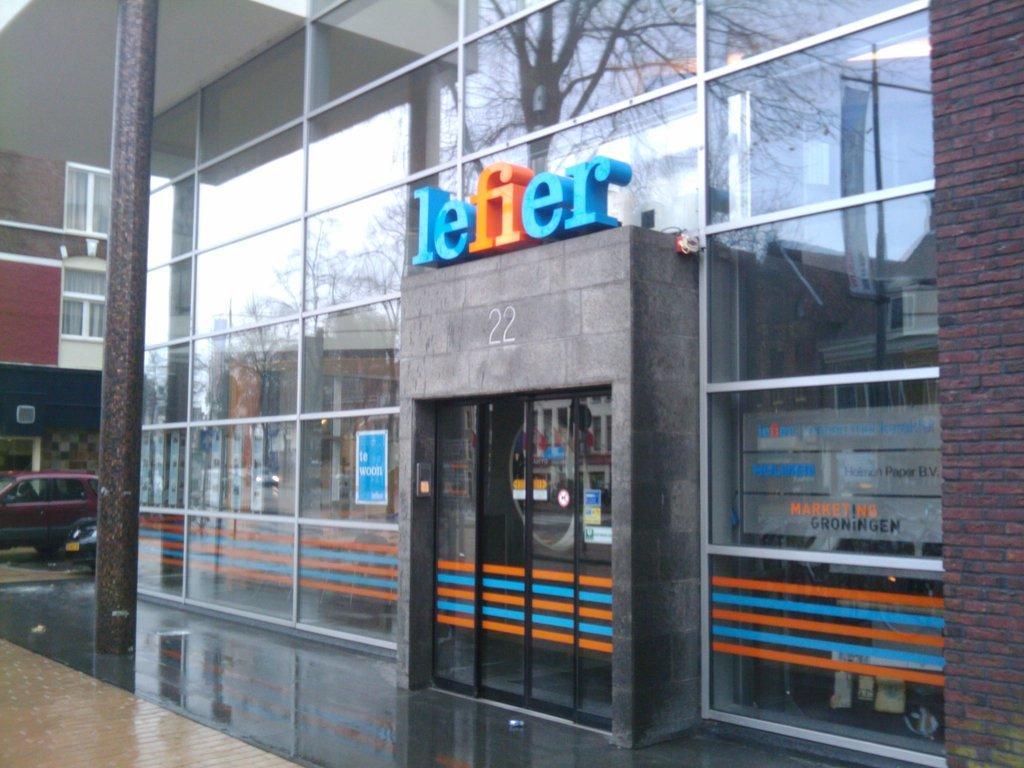In one or two sentences, can you explain what this image depicts? In this image we can see a building with glass walls. Also there is a name on the building. Near to the building there is a pillar. Also there are vehicles. And there is another building with glass windows. 